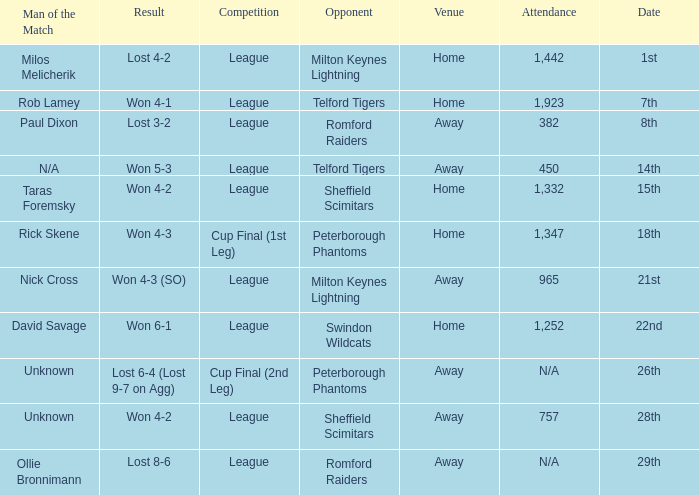Who was the Man of the Match when the opponent was Milton Keynes Lightning and the venue was Away? Nick Cross. 